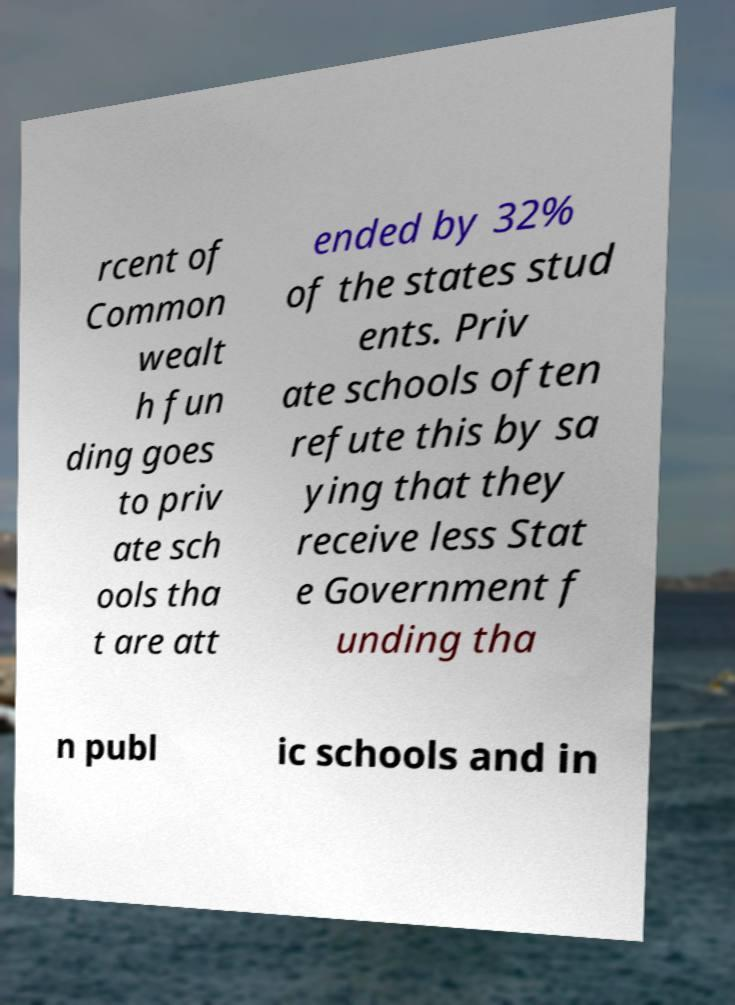Please read and relay the text visible in this image. What does it say? rcent of Common wealt h fun ding goes to priv ate sch ools tha t are att ended by 32% of the states stud ents. Priv ate schools often refute this by sa ying that they receive less Stat e Government f unding tha n publ ic schools and in 